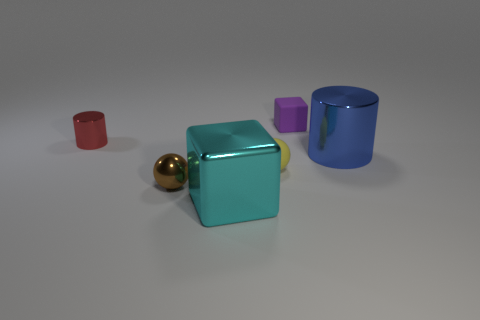What material is the sphere that is left of the big object that is in front of the big blue object made of?
Your answer should be compact. Metal. Are there any other big objects that have the same shape as the cyan object?
Your answer should be compact. No. There is a metallic cylinder that is the same size as the brown metal object; what is its color?
Make the answer very short. Red. How many objects are small things that are right of the small matte sphere or shiny cylinders in front of the red thing?
Your answer should be very brief. 2. What number of objects are yellow metallic cubes or blue metallic cylinders?
Offer a terse response. 1. There is a thing that is to the left of the yellow rubber object and behind the small brown thing; what size is it?
Your answer should be compact. Small. What number of blue things have the same material as the big block?
Provide a succinct answer. 1. What is the color of the small cube that is made of the same material as the small yellow sphere?
Make the answer very short. Purple. There is a large metallic object that is on the right side of the shiny block; does it have the same color as the big block?
Offer a very short reply. No. There is a cube that is in front of the tiny red object; what material is it?
Keep it short and to the point. Metal. 